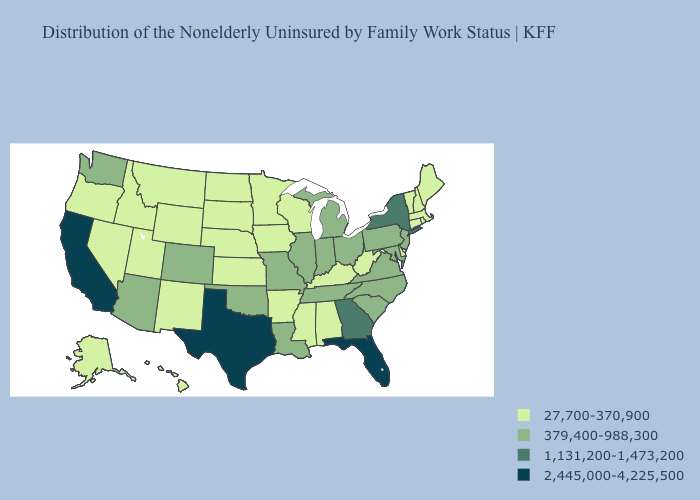Does Missouri have a lower value than Texas?
Give a very brief answer. Yes. What is the highest value in the USA?
Give a very brief answer. 2,445,000-4,225,500. Does South Carolina have the lowest value in the USA?
Answer briefly. No. Which states have the lowest value in the MidWest?
Keep it brief. Iowa, Kansas, Minnesota, Nebraska, North Dakota, South Dakota, Wisconsin. Does South Carolina have the same value as New Jersey?
Quick response, please. Yes. Name the states that have a value in the range 2,445,000-4,225,500?
Answer briefly. California, Florida, Texas. Which states have the highest value in the USA?
Give a very brief answer. California, Florida, Texas. Does Indiana have the same value as Georgia?
Give a very brief answer. No. What is the value of New Jersey?
Concise answer only. 379,400-988,300. Name the states that have a value in the range 379,400-988,300?
Give a very brief answer. Arizona, Colorado, Illinois, Indiana, Louisiana, Maryland, Michigan, Missouri, New Jersey, North Carolina, Ohio, Oklahoma, Pennsylvania, South Carolina, Tennessee, Virginia, Washington. Does the map have missing data?
Concise answer only. No. What is the lowest value in the South?
Answer briefly. 27,700-370,900. What is the value of New York?
Answer briefly. 1,131,200-1,473,200. What is the highest value in the MidWest ?
Quick response, please. 379,400-988,300. Name the states that have a value in the range 1,131,200-1,473,200?
Be succinct. Georgia, New York. 